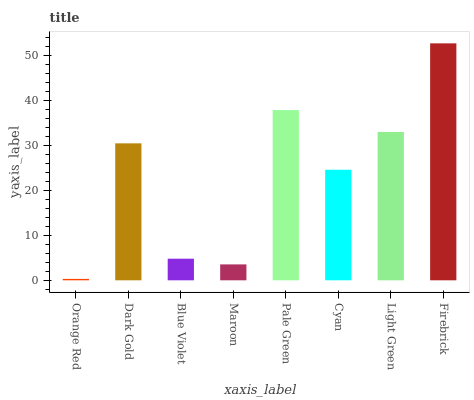Is Firebrick the maximum?
Answer yes or no. Yes. Is Dark Gold the minimum?
Answer yes or no. No. Is Dark Gold the maximum?
Answer yes or no. No. Is Dark Gold greater than Orange Red?
Answer yes or no. Yes. Is Orange Red less than Dark Gold?
Answer yes or no. Yes. Is Orange Red greater than Dark Gold?
Answer yes or no. No. Is Dark Gold less than Orange Red?
Answer yes or no. No. Is Dark Gold the high median?
Answer yes or no. Yes. Is Cyan the low median?
Answer yes or no. Yes. Is Pale Green the high median?
Answer yes or no. No. Is Dark Gold the low median?
Answer yes or no. No. 